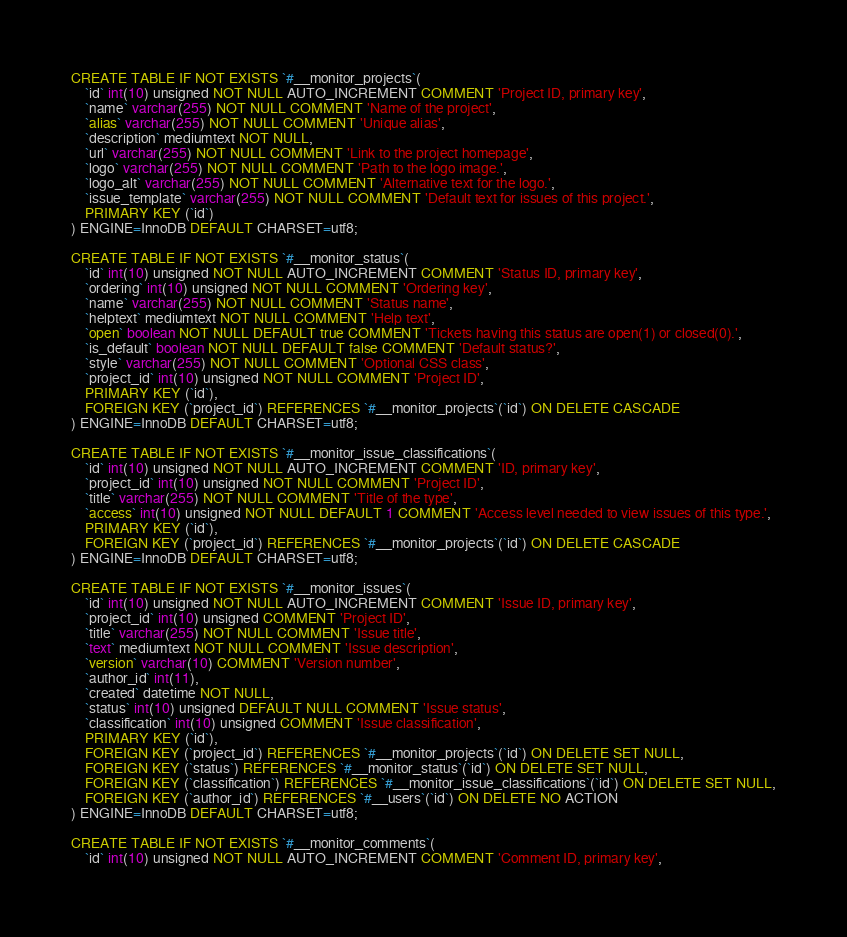<code> <loc_0><loc_0><loc_500><loc_500><_SQL_>CREATE TABLE IF NOT EXISTS `#__monitor_projects`(
	`id` int(10) unsigned NOT NULL AUTO_INCREMENT COMMENT 'Project ID, primary key',
	`name` varchar(255) NOT NULL COMMENT 'Name of the project',
	`alias` varchar(255) NOT NULL COMMENT 'Unique alias',
	`description` mediumtext NOT NULL,
	`url` varchar(255) NOT NULL COMMENT 'Link to the project homepage',
	`logo` varchar(255) NOT NULL COMMENT 'Path to the logo image.',
	`logo_alt` varchar(255) NOT NULL COMMENT 'Alternative text for the logo.',
	`issue_template` varchar(255) NOT NULL COMMENT 'Default text for issues of this project.',
	PRIMARY KEY (`id`)
) ENGINE=InnoDB DEFAULT CHARSET=utf8;

CREATE TABLE IF NOT EXISTS `#__monitor_status`(
	`id` int(10) unsigned NOT NULL AUTO_INCREMENT COMMENT 'Status ID, primary key',
	`ordering` int(10) unsigned NOT NULL COMMENT 'Ordering key',
	`name` varchar(255) NOT NULL COMMENT 'Status name',
	`helptext` mediumtext NOT NULL COMMENT 'Help text',
	`open` boolean NOT NULL DEFAULT true COMMENT 'Tickets having this status are open(1) or closed(0).',
	`is_default` boolean NOT NULL DEFAULT false COMMENT 'Default status?',
	`style` varchar(255) NOT NULL COMMENT 'Optional CSS class',
	`project_id` int(10) unsigned NOT NULL COMMENT 'Project ID',
	PRIMARY KEY (`id`),
	FOREIGN KEY (`project_id`) REFERENCES `#__monitor_projects`(`id`) ON DELETE CASCADE
) ENGINE=InnoDB DEFAULT CHARSET=utf8;

CREATE TABLE IF NOT EXISTS `#__monitor_issue_classifications`(
	`id` int(10) unsigned NOT NULL AUTO_INCREMENT COMMENT 'ID, primary key',
	`project_id` int(10) unsigned NOT NULL COMMENT 'Project ID',
	`title` varchar(255) NOT NULL COMMENT 'Title of the type',
	`access` int(10) unsigned NOT NULL DEFAULT 1 COMMENT 'Access level needed to view issues of this type.',
	PRIMARY KEY (`id`),
	FOREIGN KEY (`project_id`) REFERENCES `#__monitor_projects`(`id`) ON DELETE CASCADE
) ENGINE=InnoDB DEFAULT CHARSET=utf8;

CREATE TABLE IF NOT EXISTS `#__monitor_issues`(
	`id` int(10) unsigned NOT NULL AUTO_INCREMENT COMMENT 'Issue ID, primary key',
	`project_id` int(10) unsigned COMMENT 'Project ID',
	`title` varchar(255) NOT NULL COMMENT 'Issue title',
	`text` mediumtext NOT NULL COMMENT 'Issue description',
	`version` varchar(10) COMMENT 'Version number',
	`author_id` int(11),
	`created` datetime NOT NULL,
	`status` int(10) unsigned DEFAULT NULL COMMENT 'Issue status',
	`classification` int(10) unsigned COMMENT 'Issue classification',
	PRIMARY KEY (`id`),
	FOREIGN KEY (`project_id`) REFERENCES `#__monitor_projects`(`id`) ON DELETE SET NULL,
	FOREIGN KEY (`status`) REFERENCES `#__monitor_status`(`id`) ON DELETE SET NULL,
	FOREIGN KEY (`classification`) REFERENCES `#__monitor_issue_classifications`(`id`) ON DELETE SET NULL,
	FOREIGN KEY (`author_id`) REFERENCES `#__users`(`id`) ON DELETE NO ACTION
) ENGINE=InnoDB DEFAULT CHARSET=utf8;

CREATE TABLE IF NOT EXISTS `#__monitor_comments`(
	`id` int(10) unsigned NOT NULL AUTO_INCREMENT COMMENT 'Comment ID, primary key',</code> 